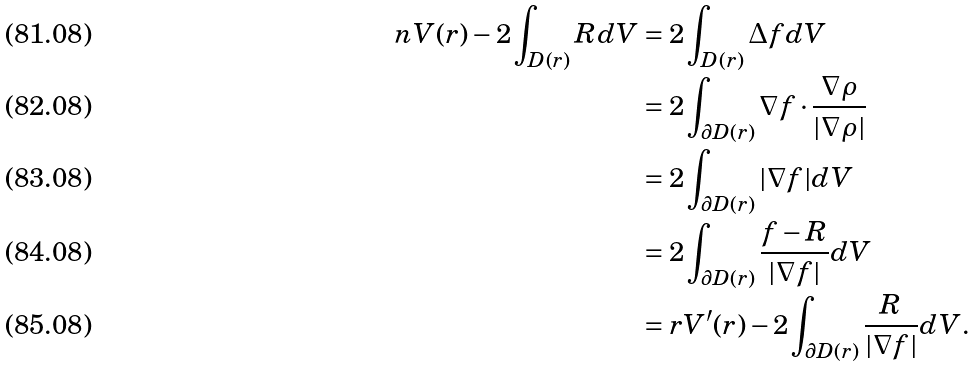<formula> <loc_0><loc_0><loc_500><loc_500>n V ( r ) - 2 \int _ { D ( r ) } { R } d V & = 2 \int _ { D ( r ) } \Delta f d V \\ & = 2 \int _ { \partial D ( r ) } \nabla f \cdot \frac { \nabla \rho } { | \nabla \rho | } \\ & = 2 \int _ { \partial D ( r ) } | \nabla f | d V \\ & = 2 \int _ { \partial D ( r ) } \frac { f - R } { | \nabla f | } d V \\ & = r V ^ { \prime } ( r ) - 2 \int _ { \partial D ( r ) } \frac { R } { | \nabla f | } d V .</formula> 